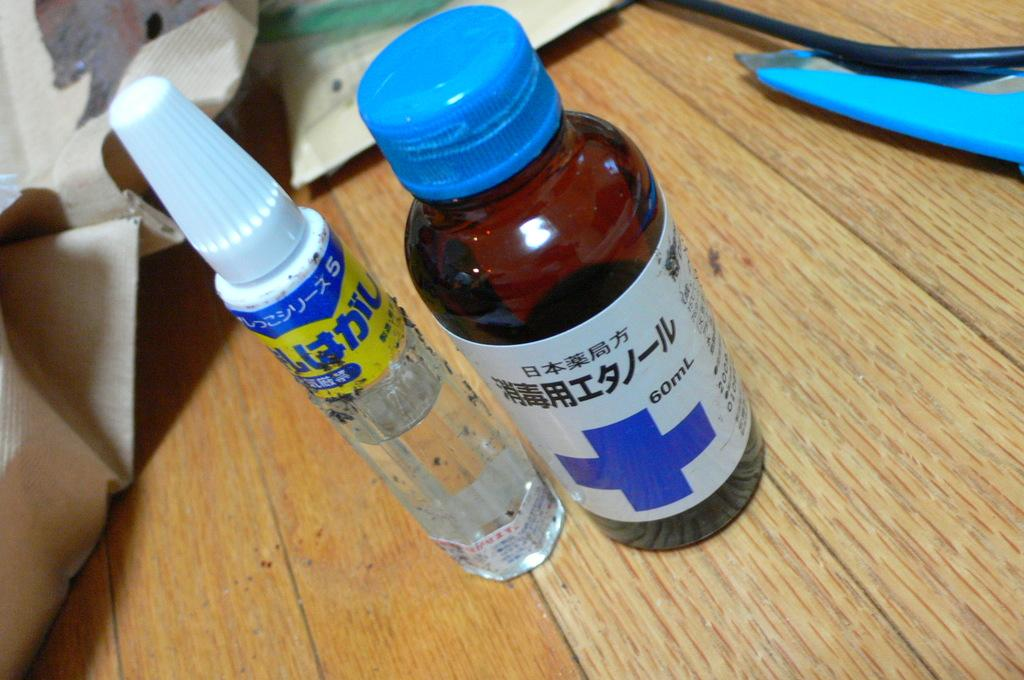<image>
Create a compact narrative representing the image presented. Medicine bottle with blue top and blue cross, 60mL in size 